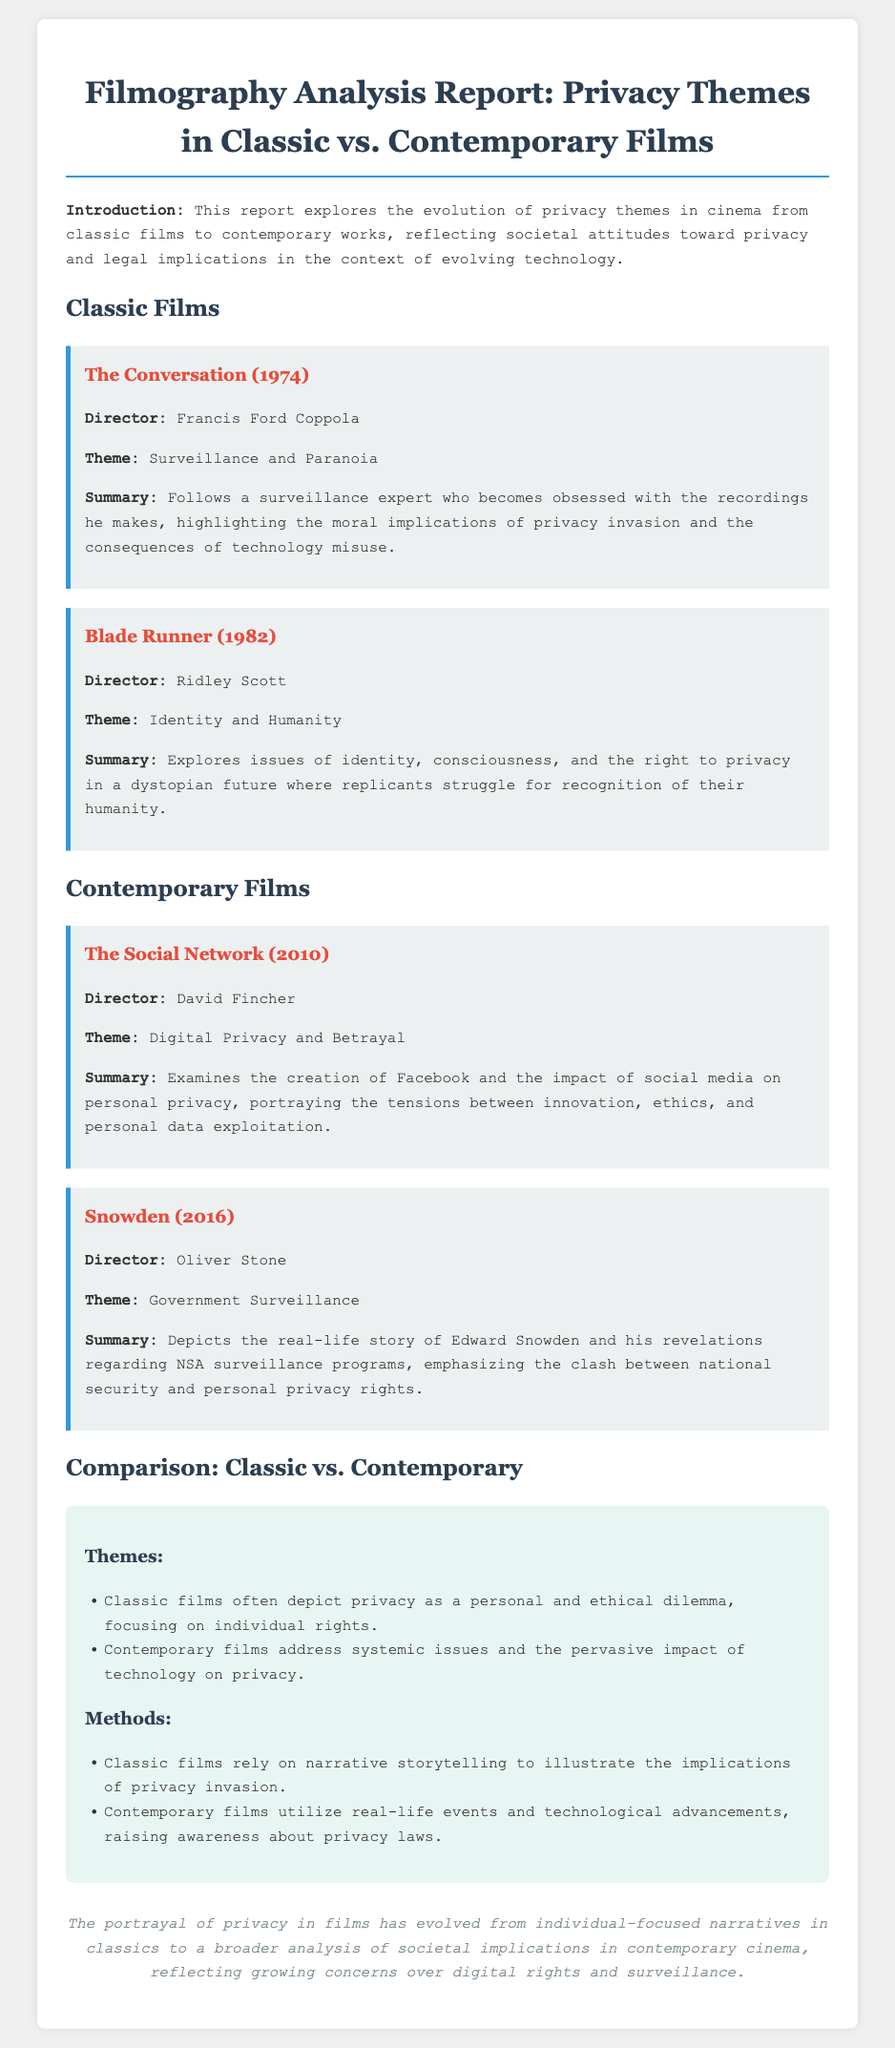What is the main theme of "The Conversation"? The report indicates that "The Conversation" focuses on surveillance and paranoia as its main theme.
Answer: Surveillance and Paranoia Who directed "Blade Runner"? The document specifically names Ridley Scott as the director of "Blade Runner".
Answer: Ridley Scott What year was "The Social Network" released? The report states that "The Social Network" was released in 2010.
Answer: 2010 What does contemporary films' analysis emphasize compared to classic films? The document explains that contemporary films address systemic issues and the pervasive impact of technology on privacy, whereas classic films focus on individual rights.
Answer: Systemic issues What is the summary focus of the film "Snowden"? According to the report, "Snowden" depicts Edward Snowden's revelations about NSA surveillance programs.
Answer: NSA surveillance programs 